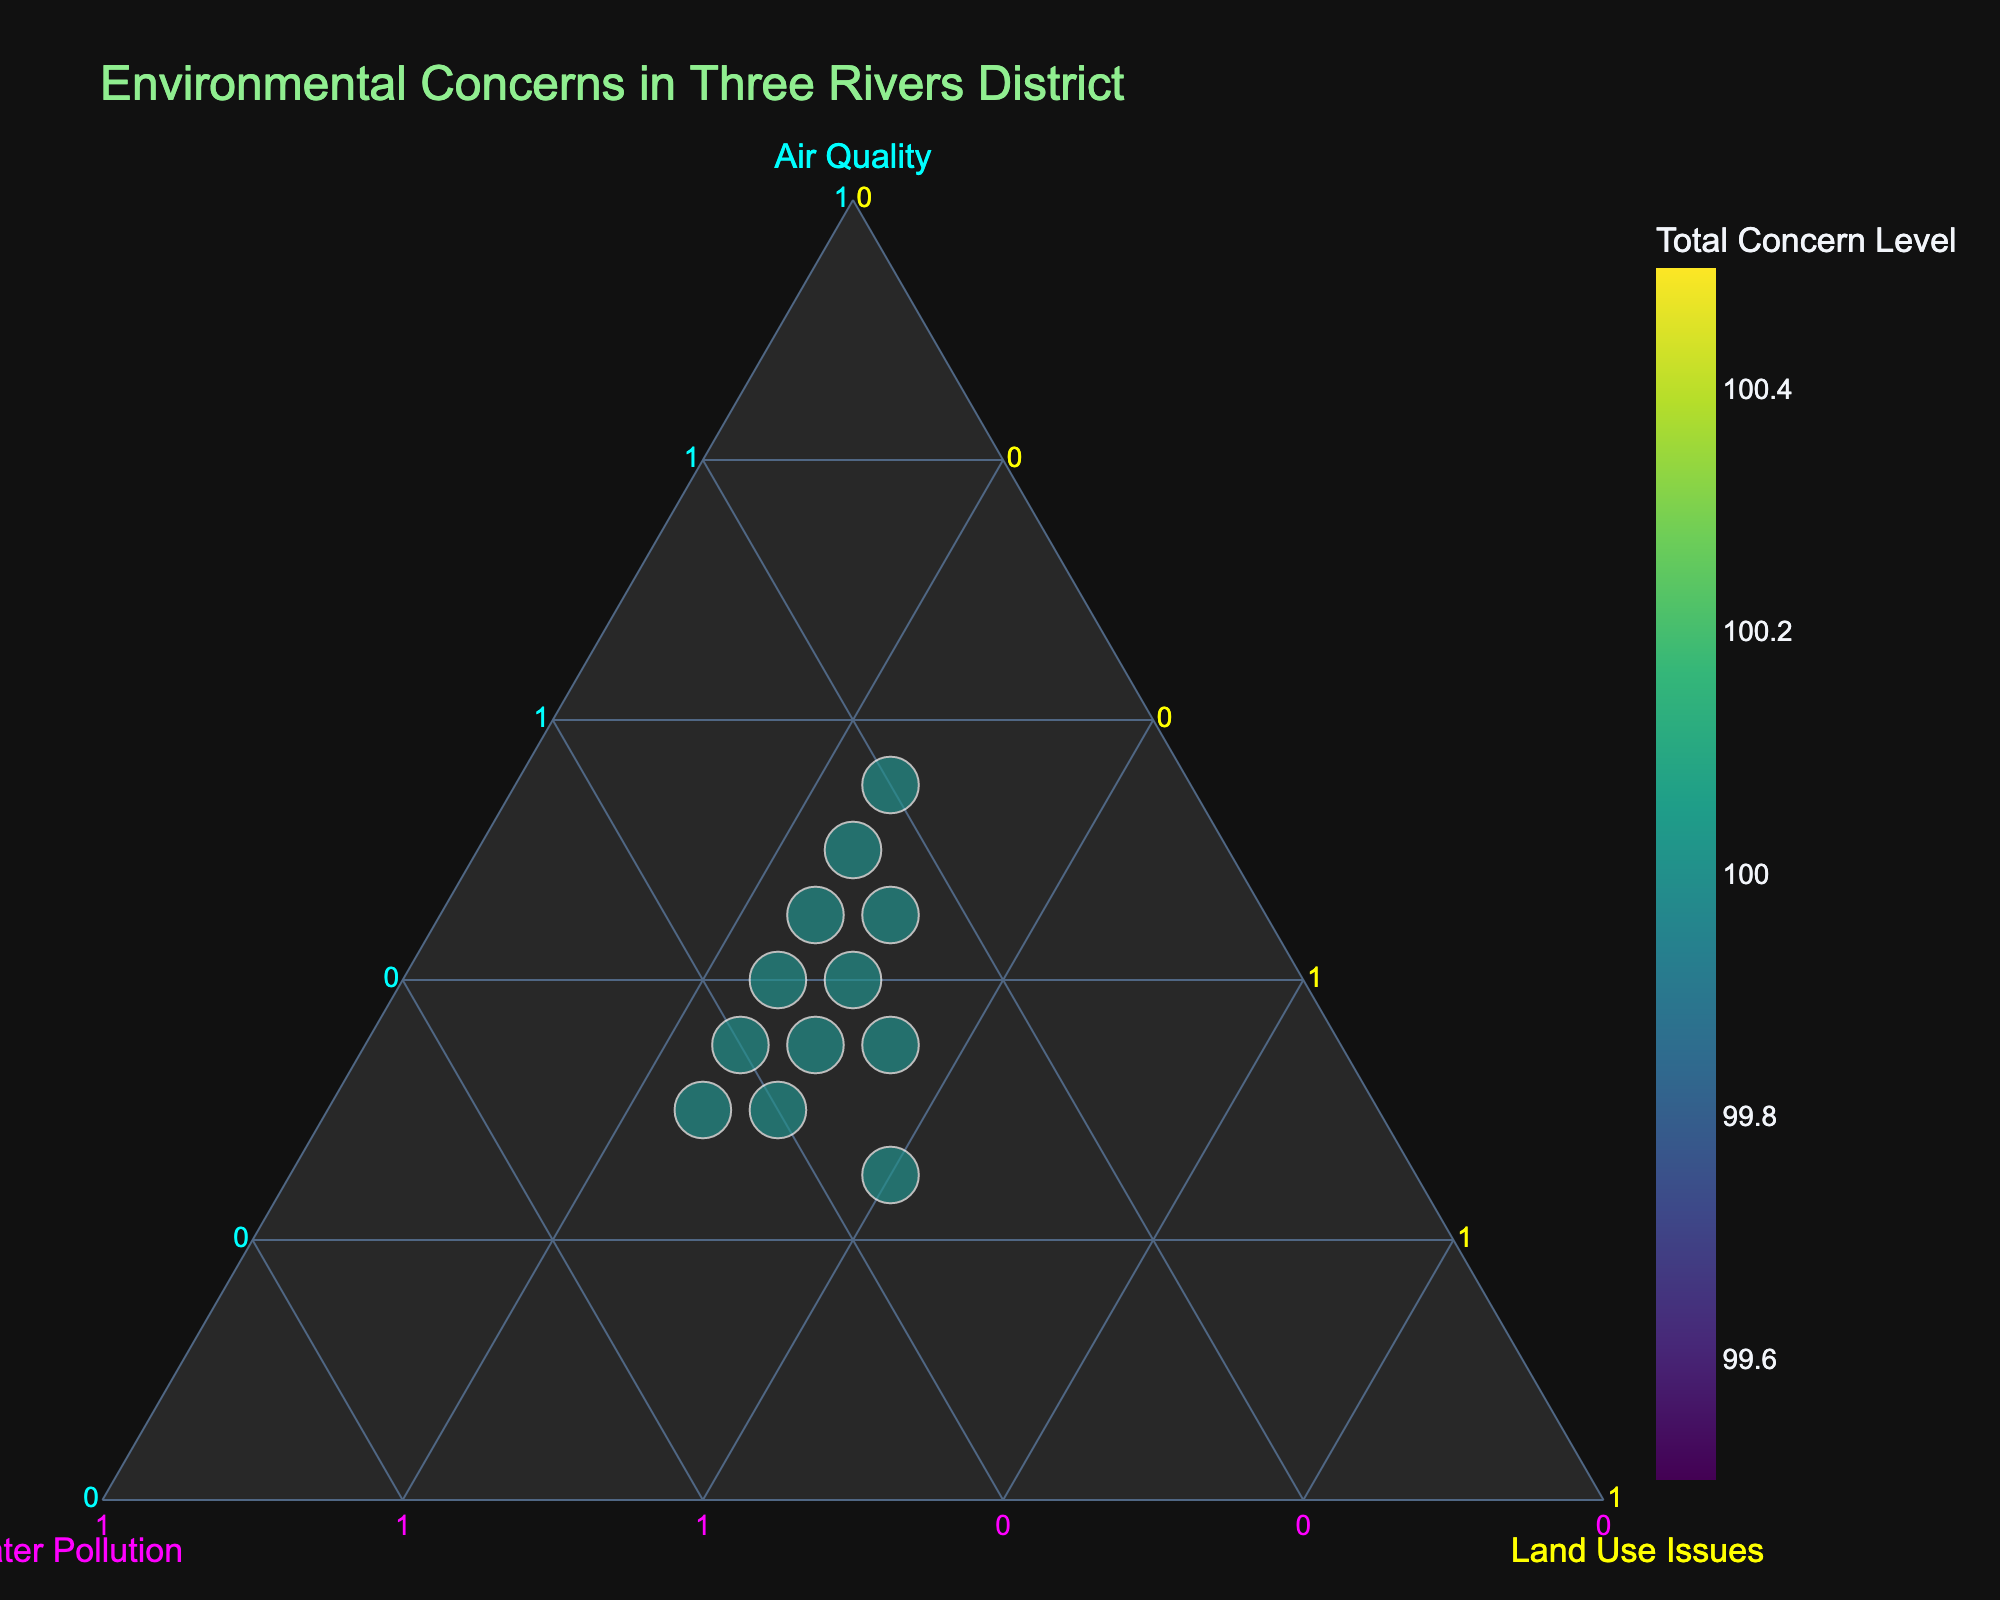How many locations are represented in the ternary plot? To determine the number of locations, look at the number of data points scattered across the ternary plot. Each point represents one location.
Answer: 12 Which location has the highest total concern level? Look for the data point with the largest size or highest color intensity in the plot since size and color both denote the total concern level.
Answer: Maple Cross Which axis represents air quality concerns? Check the title assigned to each axis of the ternary plot. The axis titled "Air Quality" will represent air quality concerns.
Answer: Left axis How does the concern for water pollution in South Oxhey compare to Rickmansworth? Compare the positions of South Oxhey and Rickmansworth along the water pollution axis. The one closer to the water pollution axis represents a higher concern level for water pollution.
Answer: Higher in South Oxhey What is the approximate air quality concern percentage for Moor Park? Find the point representing Moor Park and note its position along the air quality axis scale. This position will give the percentage of air quality concerns.
Answer: Approximately 45% Which location shows an equal distribution of concerns across air quality, water pollution, and land use issues? Identify the location whose point is roughly at the center of the ternary plot, indicating an equal distribution of 33.3% among all three concerns.
Answer: Mill End What is the combined percentage of air quality and land use issues in Croxley Green? Calculate the sum of the air quality percentage and the land use issues percentage for Croxley Green.
Answer: 75% Which location has the lowest concern for land use issues? Find the point closest to the land use axis (side representing 0% for land use issues). This point represents the location with the lowest land use concerns.
Answer: Maple Cross How does the air quality concern in Leavesden compare to Bedmond? Compare the positions of Leavesden and Bedmond along the air quality axis. The one closer to the air quality vertex has a higher air quality concern percentage.
Answer: Higher in Leavesden Which two locations have the same percentage of land use issues? Identify the points that align vertically along the land use axis and compare their hover labels to determine if their land use issue percentages match.
Answer: Abbots Langley and Bedmond 